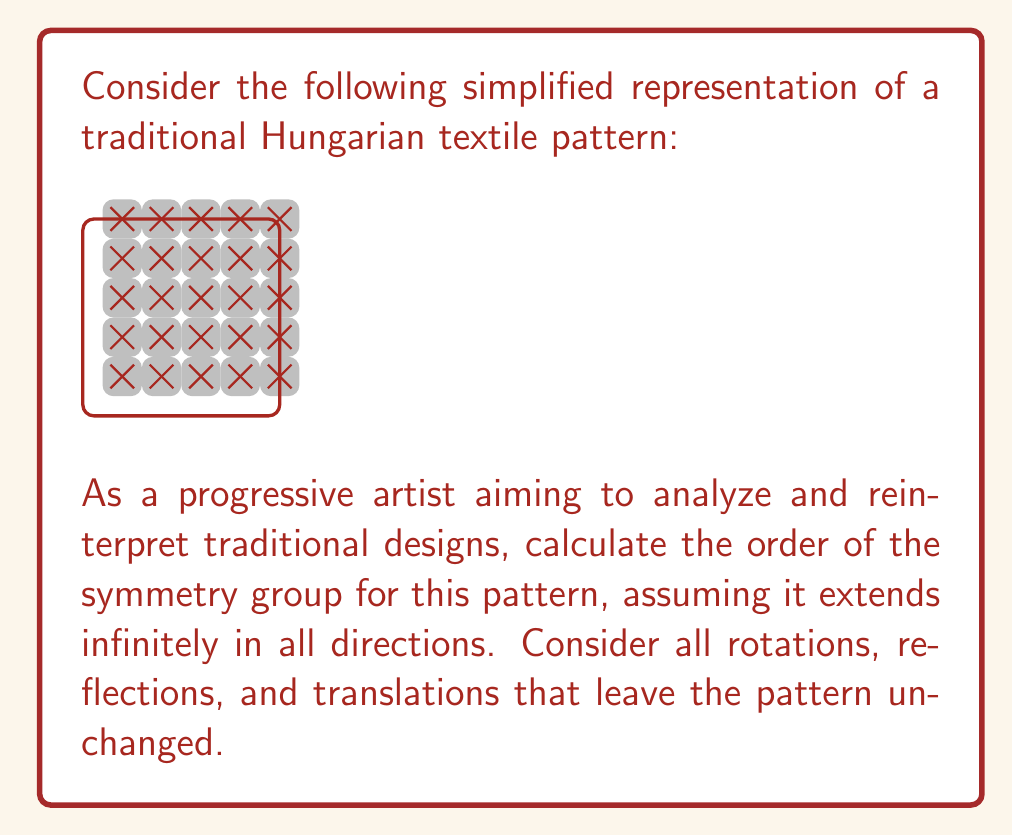Solve this math problem. To determine the order of the symmetry group, we need to identify all symmetry operations that leave the pattern unchanged. Let's analyze step-by-step:

1. Rotational symmetry:
   - The pattern has 4-fold rotational symmetry around the center of each square (90°, 180°, 270°, 360°).
   - It also has 2-fold rotational symmetry (180°) around the midpoints of the edges of each square.

2. Reflection symmetry:
   - There are vertical and horizontal reflection lines through the centers of the squares.
   - There are also diagonal reflection lines through the centers of the squares.

3. Translational symmetry:
   - The pattern can be translated horizontally and vertically by integer multiples of the square's side length.

4. Glide reflection:
   - There are glide reflections along the lines between adjacent squares.

Now, let's classify this symmetry group:

- The presence of 4-fold rotational symmetry and reflections indicates that this pattern belongs to the wallpaper group p4m.

The symmetry group p4m has the following generators:
- 90° rotation
- Reflection
- Two perpendicular translations

The order of the p4m group is infinite due to the infinite number of translations. However, if we consider only the symmetries within a single unit cell (one square), we can calculate a finite subgroup order:

- 4 rotations (0°, 90°, 180°, 270°)
- 4 reflections (vertical, horizontal, and two diagonal)
- 1 identity transformation

Therefore, the order of the symmetry group for a single unit cell is 4 + 4 + 1 = 9.
Answer: Infinite (wallpaper group p4m); 9 (for single unit cell) 